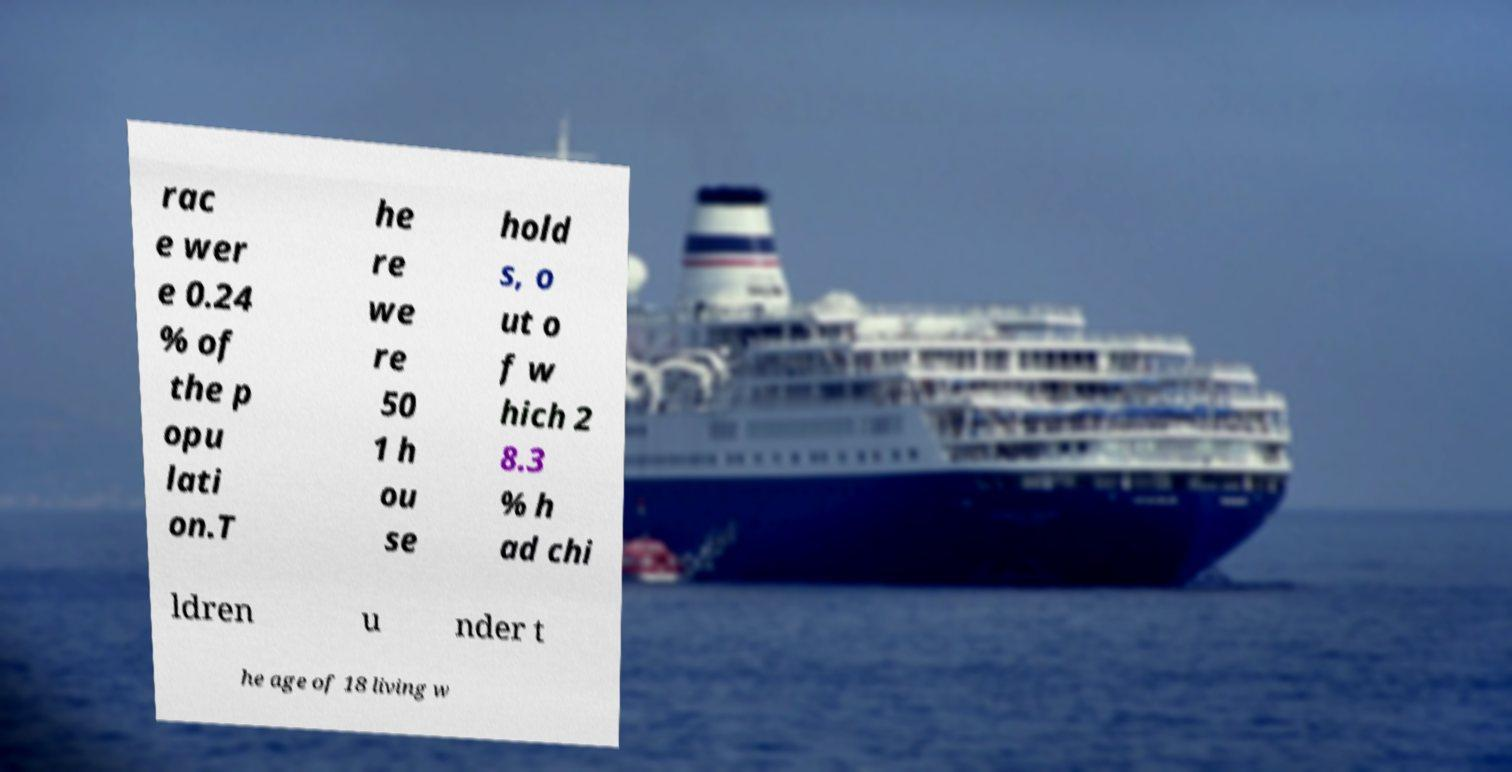What messages or text are displayed in this image? I need them in a readable, typed format. rac e wer e 0.24 % of the p opu lati on.T he re we re 50 1 h ou se hold s, o ut o f w hich 2 8.3 % h ad chi ldren u nder t he age of 18 living w 